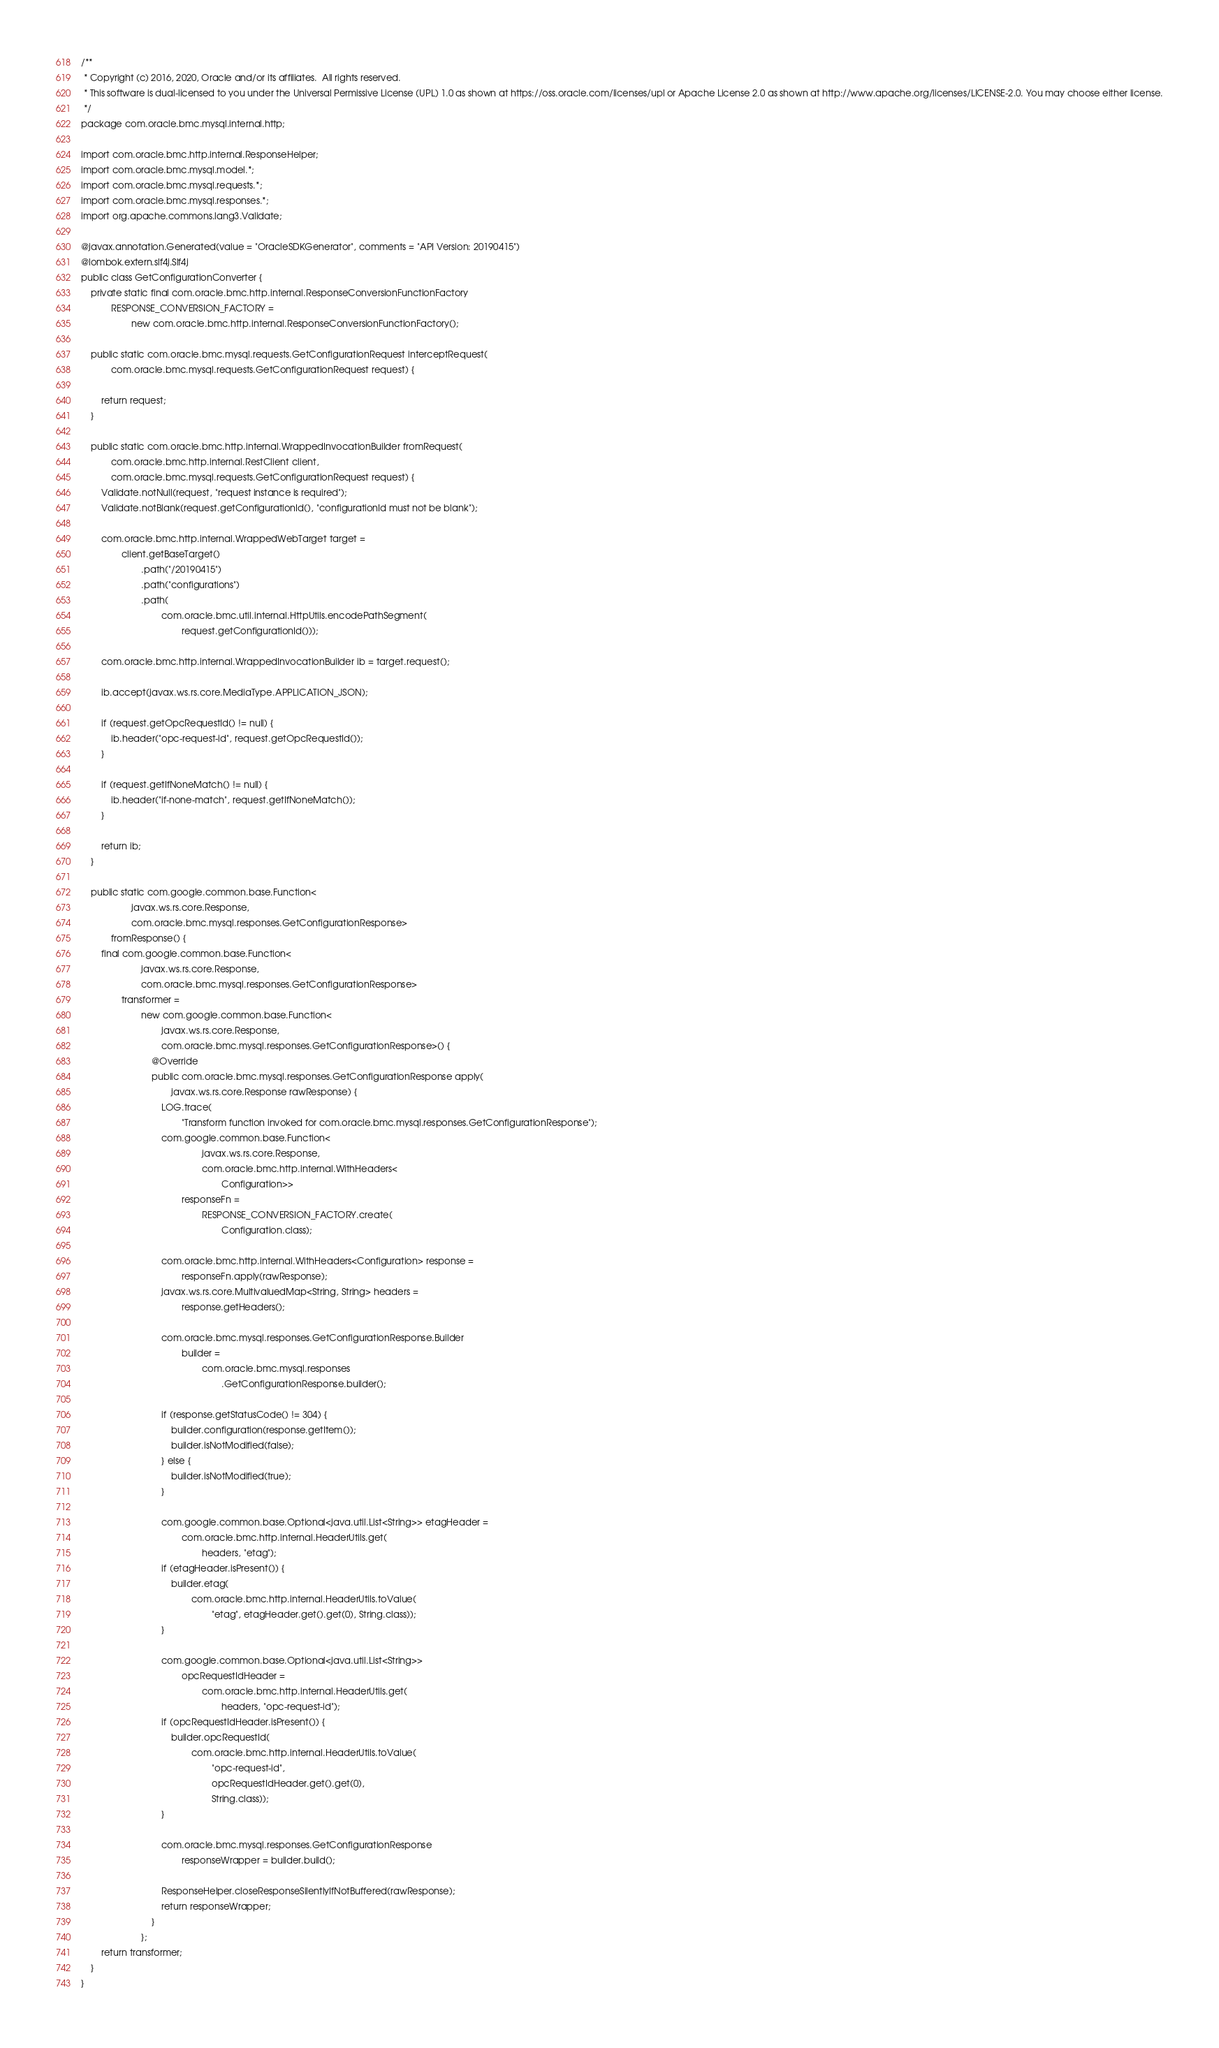Convert code to text. <code><loc_0><loc_0><loc_500><loc_500><_Java_>/**
 * Copyright (c) 2016, 2020, Oracle and/or its affiliates.  All rights reserved.
 * This software is dual-licensed to you under the Universal Permissive License (UPL) 1.0 as shown at https://oss.oracle.com/licenses/upl or Apache License 2.0 as shown at http://www.apache.org/licenses/LICENSE-2.0. You may choose either license.
 */
package com.oracle.bmc.mysql.internal.http;

import com.oracle.bmc.http.internal.ResponseHelper;
import com.oracle.bmc.mysql.model.*;
import com.oracle.bmc.mysql.requests.*;
import com.oracle.bmc.mysql.responses.*;
import org.apache.commons.lang3.Validate;

@javax.annotation.Generated(value = "OracleSDKGenerator", comments = "API Version: 20190415")
@lombok.extern.slf4j.Slf4j
public class GetConfigurationConverter {
    private static final com.oracle.bmc.http.internal.ResponseConversionFunctionFactory
            RESPONSE_CONVERSION_FACTORY =
                    new com.oracle.bmc.http.internal.ResponseConversionFunctionFactory();

    public static com.oracle.bmc.mysql.requests.GetConfigurationRequest interceptRequest(
            com.oracle.bmc.mysql.requests.GetConfigurationRequest request) {

        return request;
    }

    public static com.oracle.bmc.http.internal.WrappedInvocationBuilder fromRequest(
            com.oracle.bmc.http.internal.RestClient client,
            com.oracle.bmc.mysql.requests.GetConfigurationRequest request) {
        Validate.notNull(request, "request instance is required");
        Validate.notBlank(request.getConfigurationId(), "configurationId must not be blank");

        com.oracle.bmc.http.internal.WrappedWebTarget target =
                client.getBaseTarget()
                        .path("/20190415")
                        .path("configurations")
                        .path(
                                com.oracle.bmc.util.internal.HttpUtils.encodePathSegment(
                                        request.getConfigurationId()));

        com.oracle.bmc.http.internal.WrappedInvocationBuilder ib = target.request();

        ib.accept(javax.ws.rs.core.MediaType.APPLICATION_JSON);

        if (request.getOpcRequestId() != null) {
            ib.header("opc-request-id", request.getOpcRequestId());
        }

        if (request.getIfNoneMatch() != null) {
            ib.header("if-none-match", request.getIfNoneMatch());
        }

        return ib;
    }

    public static com.google.common.base.Function<
                    javax.ws.rs.core.Response,
                    com.oracle.bmc.mysql.responses.GetConfigurationResponse>
            fromResponse() {
        final com.google.common.base.Function<
                        javax.ws.rs.core.Response,
                        com.oracle.bmc.mysql.responses.GetConfigurationResponse>
                transformer =
                        new com.google.common.base.Function<
                                javax.ws.rs.core.Response,
                                com.oracle.bmc.mysql.responses.GetConfigurationResponse>() {
                            @Override
                            public com.oracle.bmc.mysql.responses.GetConfigurationResponse apply(
                                    javax.ws.rs.core.Response rawResponse) {
                                LOG.trace(
                                        "Transform function invoked for com.oracle.bmc.mysql.responses.GetConfigurationResponse");
                                com.google.common.base.Function<
                                                javax.ws.rs.core.Response,
                                                com.oracle.bmc.http.internal.WithHeaders<
                                                        Configuration>>
                                        responseFn =
                                                RESPONSE_CONVERSION_FACTORY.create(
                                                        Configuration.class);

                                com.oracle.bmc.http.internal.WithHeaders<Configuration> response =
                                        responseFn.apply(rawResponse);
                                javax.ws.rs.core.MultivaluedMap<String, String> headers =
                                        response.getHeaders();

                                com.oracle.bmc.mysql.responses.GetConfigurationResponse.Builder
                                        builder =
                                                com.oracle.bmc.mysql.responses
                                                        .GetConfigurationResponse.builder();

                                if (response.getStatusCode() != 304) {
                                    builder.configuration(response.getItem());
                                    builder.isNotModified(false);
                                } else {
                                    builder.isNotModified(true);
                                }

                                com.google.common.base.Optional<java.util.List<String>> etagHeader =
                                        com.oracle.bmc.http.internal.HeaderUtils.get(
                                                headers, "etag");
                                if (etagHeader.isPresent()) {
                                    builder.etag(
                                            com.oracle.bmc.http.internal.HeaderUtils.toValue(
                                                    "etag", etagHeader.get().get(0), String.class));
                                }

                                com.google.common.base.Optional<java.util.List<String>>
                                        opcRequestIdHeader =
                                                com.oracle.bmc.http.internal.HeaderUtils.get(
                                                        headers, "opc-request-id");
                                if (opcRequestIdHeader.isPresent()) {
                                    builder.opcRequestId(
                                            com.oracle.bmc.http.internal.HeaderUtils.toValue(
                                                    "opc-request-id",
                                                    opcRequestIdHeader.get().get(0),
                                                    String.class));
                                }

                                com.oracle.bmc.mysql.responses.GetConfigurationResponse
                                        responseWrapper = builder.build();

                                ResponseHelper.closeResponseSilentlyIfNotBuffered(rawResponse);
                                return responseWrapper;
                            }
                        };
        return transformer;
    }
}
</code> 